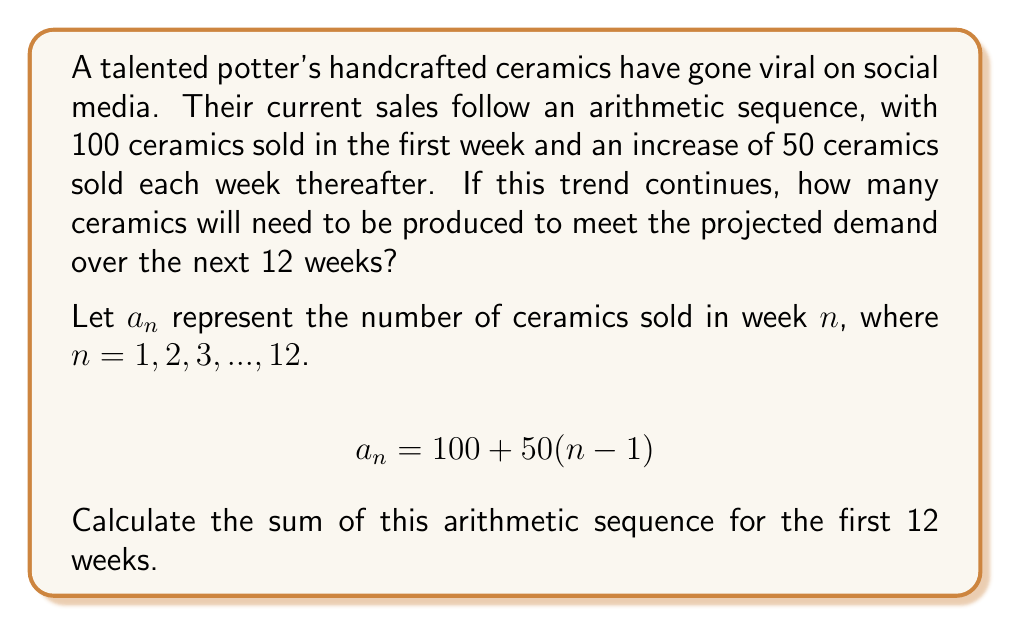Give your solution to this math problem. To solve this problem, we need to find the sum of an arithmetic sequence for the first 12 terms. We can use the formula for the sum of an arithmetic sequence:

$$S_n = \frac{n}{2}(a_1 + a_n)$$

Where:
$S_n$ is the sum of the first $n$ terms
$n$ is the number of terms
$a_1$ is the first term
$a_n$ is the last term

We know:
$n = 12$ (12 weeks)
$a_1 = 100$ (first week's sales)

To find $a_{12}$ (the 12th week's sales), we use the arithmetic sequence formula:
$$a_n = a_1 + (n-1)d$$
Where $d$ is the common difference (50 in this case)

$$a_{12} = 100 + (12-1)50 = 100 + 550 = 650$$

Now we can substitute these values into the sum formula:

$$S_{12} = \frac{12}{2}(100 + 650)$$
$$S_{12} = 6(750)$$
$$S_{12} = 4500$$

Therefore, the total number of ceramics needed to meet the projected demand over the next 12 weeks is 4500.
Answer: 4500 ceramics 